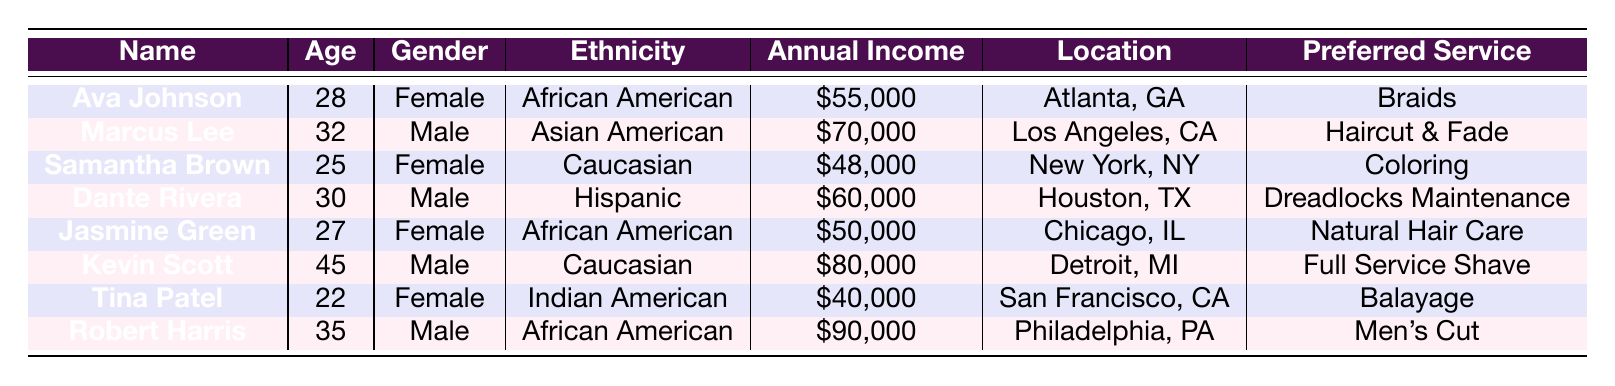What is the preferred service of Ava Johnson? By looking at the table, I can see that Ava Johnson's row lists her preferred service under the "Preferred Service" column, which is "Braids".
Answer: Braids How old is Kevin Scott? I check the row for Kevin Scott in the table, and I see that the "Age" column states he is 45 years old.
Answer: 45 What is the annual income of Robert Harris? In Robert Harris's row, the "Annual Income" column shows "$90,000".
Answer: $90,000 Are there any female clients aged 30 or older? To find this out, I look for female clients in the table and check their ages. The only female client aged 30 or older is Ava Johnson at age 28, so the answer is no.
Answer: No Which client has the highest annual income? I need to compare the annual income values from each row. The highest value listed is "$90,000" for Robert Harris.
Answer: Robert Harris How many clients prefer a service that requires maintenance? I review the "Preferred Service" column and see that both Ava Johnson (Braids) and Dante Rivera (Dreadlocks Maintenance) indicate a maintenance-type service, totaling two clients.
Answer: 2 Is it true that all clients from Chicago prefer Natural Hair Care? I check the table and find that only Jasmine Green is listed as being from Chicago and her preferred service is Natural Hair Care, indicating that the statement is true but only for her.
Answer: True What is the average age of the clients listed? I sum the ages (28 + 32 + 25 + 30 + 27 + 45 + 22 + 35) to get a total of 249. There are 8 clients, so I divide 249 by 8, which gives an average age of 31.125.
Answer: 31.125 What is the difference in annual income between the youngest and oldest clients? The youngest client is Tina Patel with an income of $40,000, and the oldest client is Kevin Scott with an income of $80,000. The difference is $80,000 - $40,000 = $40,000.
Answer: $40,000 Which city has the second highest income client? After checking the table, I see that the incomes are $90,000 for Philadelphia, $80,000 for Detroit, $70,000 for Los Angeles, and so on. The second highest income is from Kevin Scott in Detroit at $80,000.
Answer: Detroit 